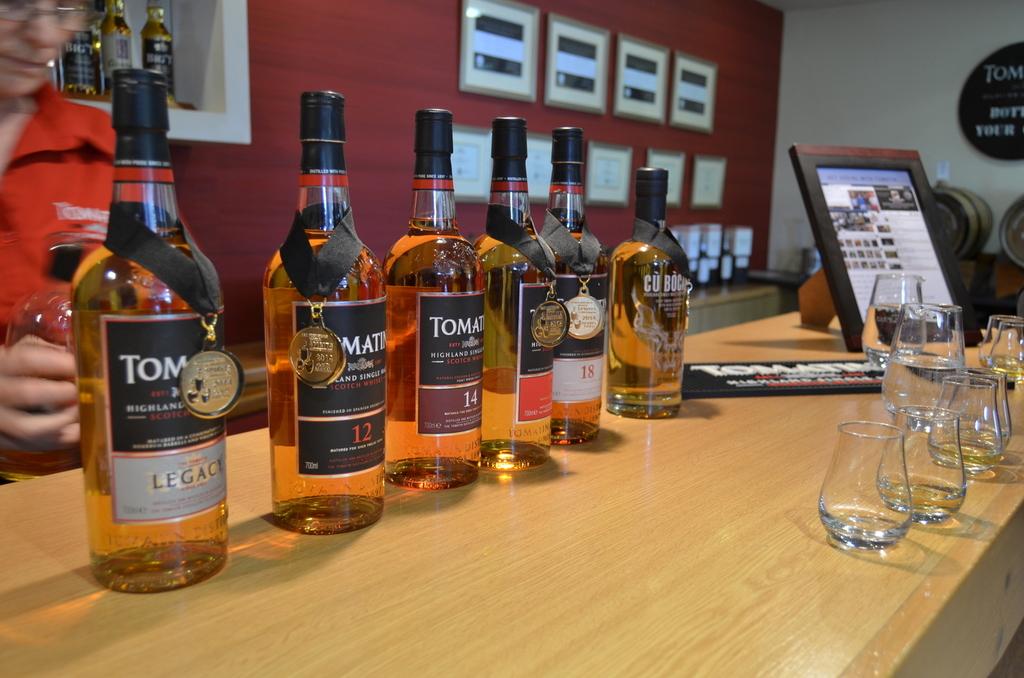What number is on the label on the second bottle on the left?
Your response must be concise. 12. What number is on the label on the third bottle on the left?
Keep it short and to the point. 14. 